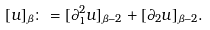Convert formula to latex. <formula><loc_0><loc_0><loc_500><loc_500>[ u ] _ { \beta } \colon = [ \partial _ { 1 } ^ { 2 } u ] _ { \beta - 2 } + [ \partial _ { 2 } u ] _ { \beta - 2 } .</formula> 